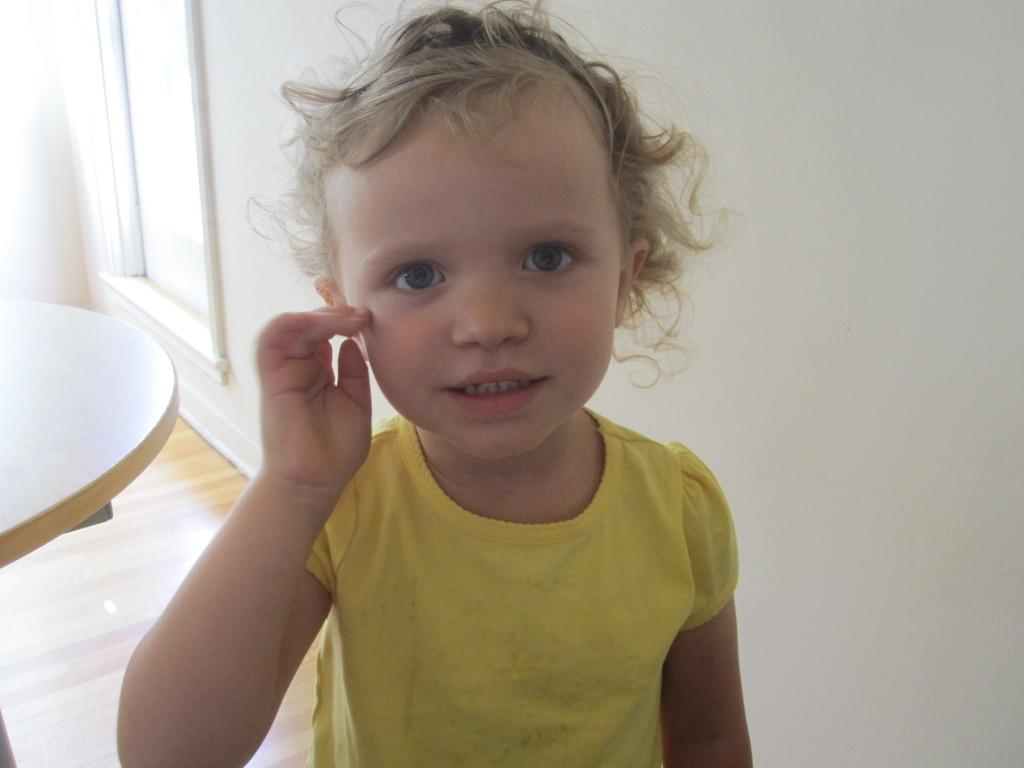Who is the main subject in the image? There is a girl in the image. What is the girl wearing? The girl is wearing a yellow dress. What can be seen to the left of the girl? There is a table to the left of the girl. What is visible in the background of the image? There is a window and a white wall in the background. What type of sofa can be seen in the image? There is no sofa present in the image. How much was the payment for the girl's yellow dress in the image? There is no information about payment for the dress in the image. 